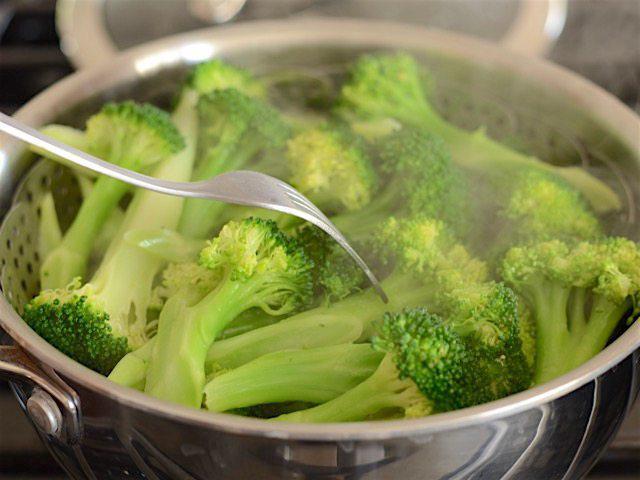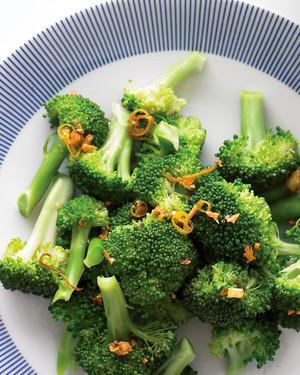The first image is the image on the left, the second image is the image on the right. Evaluate the accuracy of this statement regarding the images: "In one image, broccoli florets are being steamed in a metal pot.". Is it true? Answer yes or no. Yes. The first image is the image on the left, the second image is the image on the right. Examine the images to the left and right. Is the description "The left and right image contains the same number of white plates with broccoli." accurate? Answer yes or no. No. 